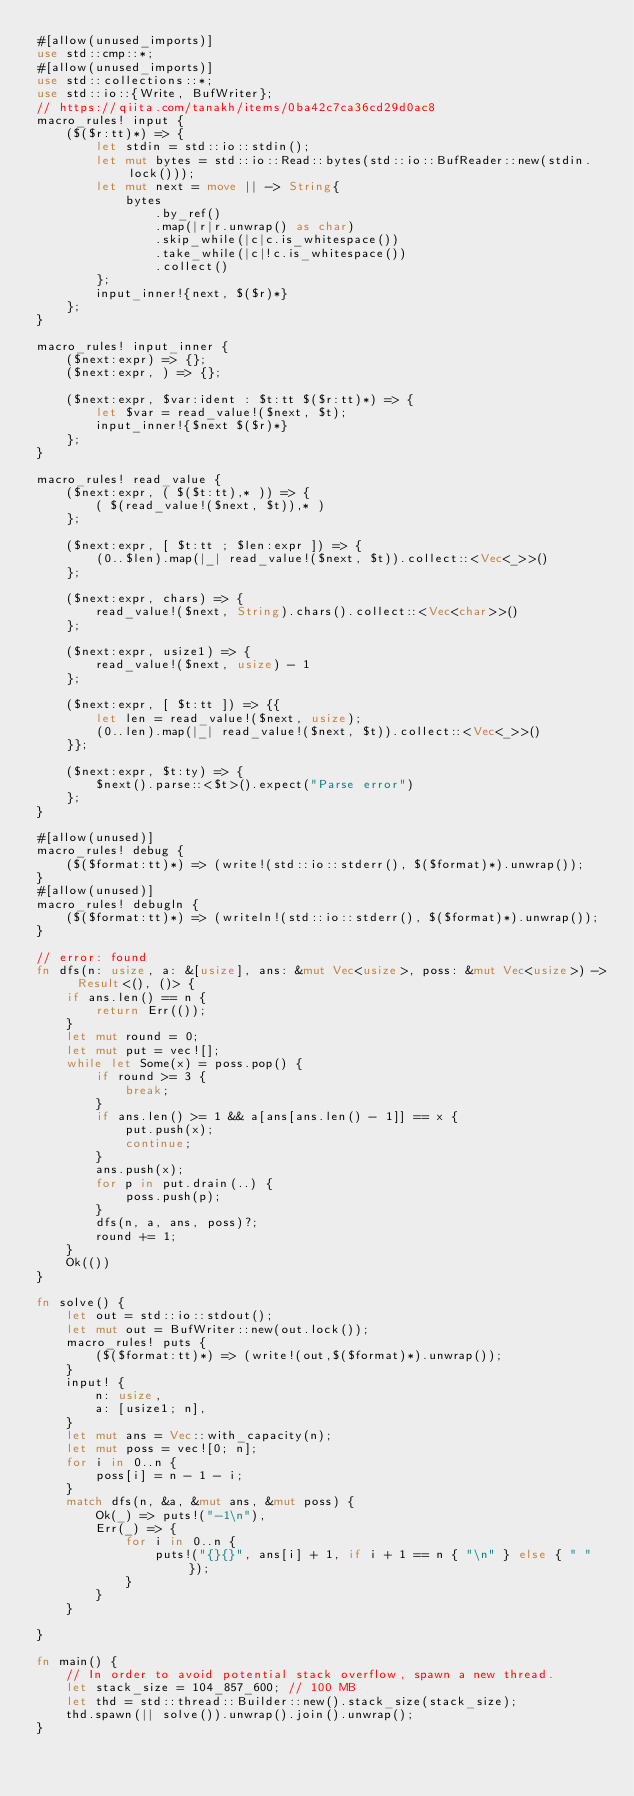<code> <loc_0><loc_0><loc_500><loc_500><_Rust_>#[allow(unused_imports)]
use std::cmp::*;
#[allow(unused_imports)]
use std::collections::*;
use std::io::{Write, BufWriter};
// https://qiita.com/tanakh/items/0ba42c7ca36cd29d0ac8
macro_rules! input {
    ($($r:tt)*) => {
        let stdin = std::io::stdin();
        let mut bytes = std::io::Read::bytes(std::io::BufReader::new(stdin.lock()));
        let mut next = move || -> String{
            bytes
                .by_ref()
                .map(|r|r.unwrap() as char)
                .skip_while(|c|c.is_whitespace())
                .take_while(|c|!c.is_whitespace())
                .collect()
        };
        input_inner!{next, $($r)*}
    };
}

macro_rules! input_inner {
    ($next:expr) => {};
    ($next:expr, ) => {};

    ($next:expr, $var:ident : $t:tt $($r:tt)*) => {
        let $var = read_value!($next, $t);
        input_inner!{$next $($r)*}
    };
}

macro_rules! read_value {
    ($next:expr, ( $($t:tt),* )) => {
        ( $(read_value!($next, $t)),* )
    };

    ($next:expr, [ $t:tt ; $len:expr ]) => {
        (0..$len).map(|_| read_value!($next, $t)).collect::<Vec<_>>()
    };

    ($next:expr, chars) => {
        read_value!($next, String).chars().collect::<Vec<char>>()
    };

    ($next:expr, usize1) => {
        read_value!($next, usize) - 1
    };

    ($next:expr, [ $t:tt ]) => {{
        let len = read_value!($next, usize);
        (0..len).map(|_| read_value!($next, $t)).collect::<Vec<_>>()
    }};

    ($next:expr, $t:ty) => {
        $next().parse::<$t>().expect("Parse error")
    };
}

#[allow(unused)]
macro_rules! debug {
    ($($format:tt)*) => (write!(std::io::stderr(), $($format)*).unwrap());
}
#[allow(unused)]
macro_rules! debugln {
    ($($format:tt)*) => (writeln!(std::io::stderr(), $($format)*).unwrap());
}

// error: found
fn dfs(n: usize, a: &[usize], ans: &mut Vec<usize>, poss: &mut Vec<usize>) -> Result<(), ()> {
    if ans.len() == n {
        return Err(());
    }
    let mut round = 0;
    let mut put = vec![];
    while let Some(x) = poss.pop() {
        if round >= 3 {
            break;
        }
        if ans.len() >= 1 && a[ans[ans.len() - 1]] == x {
            put.push(x);
            continue;
        }
        ans.push(x);
        for p in put.drain(..) {
            poss.push(p);
        }
        dfs(n, a, ans, poss)?;
        round += 1;
    }
    Ok(())
}

fn solve() {
    let out = std::io::stdout();
    let mut out = BufWriter::new(out.lock());
    macro_rules! puts {
        ($($format:tt)*) => (write!(out,$($format)*).unwrap());
    }
    input! {
        n: usize,
        a: [usize1; n],
    }
    let mut ans = Vec::with_capacity(n);
    let mut poss = vec![0; n];
    for i in 0..n {
        poss[i] = n - 1 - i;
    }
    match dfs(n, &a, &mut ans, &mut poss) {
        Ok(_) => puts!("-1\n"),
        Err(_) => {
            for i in 0..n {
                puts!("{}{}", ans[i] + 1, if i + 1 == n { "\n" } else { " " });
            }
        }
    }
    
}

fn main() {
    // In order to avoid potential stack overflow, spawn a new thread.
    let stack_size = 104_857_600; // 100 MB
    let thd = std::thread::Builder::new().stack_size(stack_size);
    thd.spawn(|| solve()).unwrap().join().unwrap();
}
</code> 